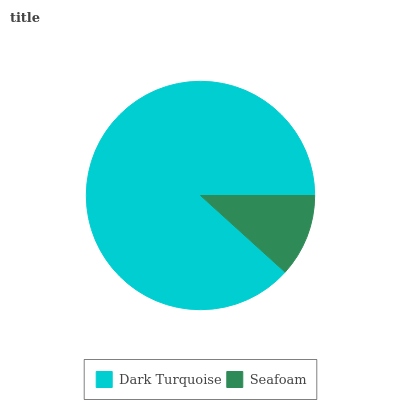Is Seafoam the minimum?
Answer yes or no. Yes. Is Dark Turquoise the maximum?
Answer yes or no. Yes. Is Seafoam the maximum?
Answer yes or no. No. Is Dark Turquoise greater than Seafoam?
Answer yes or no. Yes. Is Seafoam less than Dark Turquoise?
Answer yes or no. Yes. Is Seafoam greater than Dark Turquoise?
Answer yes or no. No. Is Dark Turquoise less than Seafoam?
Answer yes or no. No. Is Dark Turquoise the high median?
Answer yes or no. Yes. Is Seafoam the low median?
Answer yes or no. Yes. Is Seafoam the high median?
Answer yes or no. No. Is Dark Turquoise the low median?
Answer yes or no. No. 